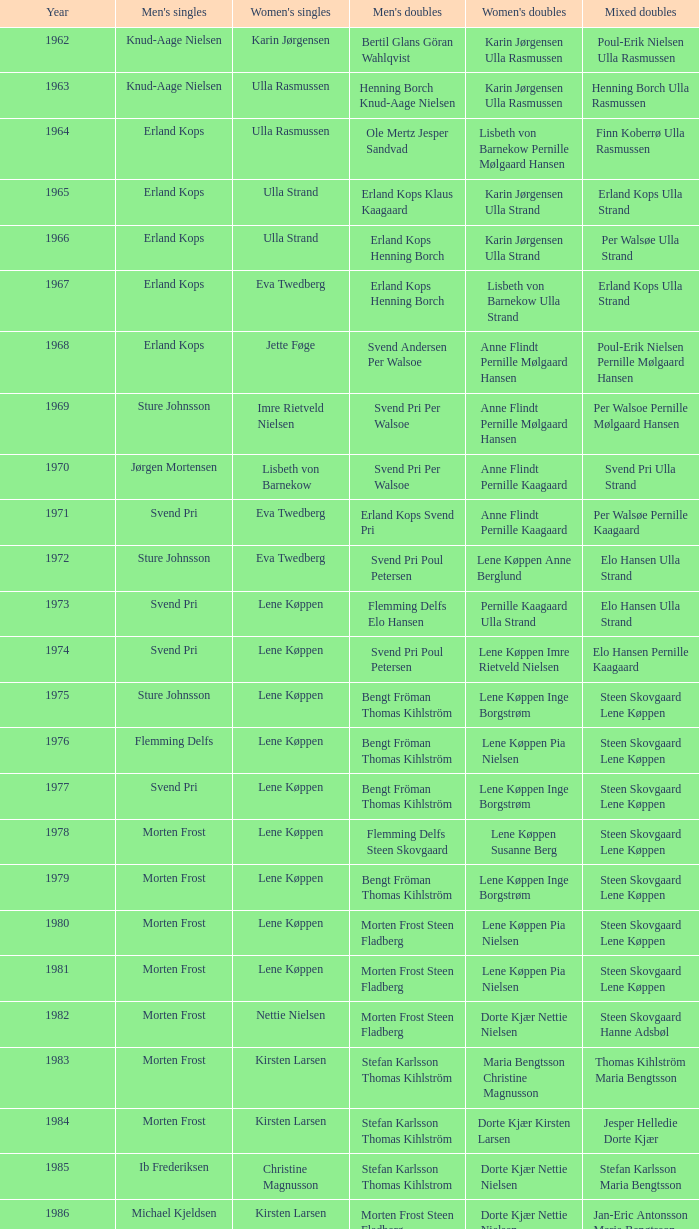Help me parse the entirety of this table. {'header': ['Year', "Men's singles", "Women's singles", "Men's doubles", "Women's doubles", 'Mixed doubles'], 'rows': [['1962', 'Knud-Aage Nielsen', 'Karin Jørgensen', 'Bertil Glans Göran Wahlqvist', 'Karin Jørgensen Ulla Rasmussen', 'Poul-Erik Nielsen Ulla Rasmussen'], ['1963', 'Knud-Aage Nielsen', 'Ulla Rasmussen', 'Henning Borch Knud-Aage Nielsen', 'Karin Jørgensen Ulla Rasmussen', 'Henning Borch Ulla Rasmussen'], ['1964', 'Erland Kops', 'Ulla Rasmussen', 'Ole Mertz Jesper Sandvad', 'Lisbeth von Barnekow Pernille Mølgaard Hansen', 'Finn Koberrø Ulla Rasmussen'], ['1965', 'Erland Kops', 'Ulla Strand', 'Erland Kops Klaus Kaagaard', 'Karin Jørgensen Ulla Strand', 'Erland Kops Ulla Strand'], ['1966', 'Erland Kops', 'Ulla Strand', 'Erland Kops Henning Borch', 'Karin Jørgensen Ulla Strand', 'Per Walsøe Ulla Strand'], ['1967', 'Erland Kops', 'Eva Twedberg', 'Erland Kops Henning Borch', 'Lisbeth von Barnekow Ulla Strand', 'Erland Kops Ulla Strand'], ['1968', 'Erland Kops', 'Jette Føge', 'Svend Andersen Per Walsoe', 'Anne Flindt Pernille Mølgaard Hansen', 'Poul-Erik Nielsen Pernille Mølgaard Hansen'], ['1969', 'Sture Johnsson', 'Imre Rietveld Nielsen', 'Svend Pri Per Walsoe', 'Anne Flindt Pernille Mølgaard Hansen', 'Per Walsoe Pernille Mølgaard Hansen'], ['1970', 'Jørgen Mortensen', 'Lisbeth von Barnekow', 'Svend Pri Per Walsoe', 'Anne Flindt Pernille Kaagaard', 'Svend Pri Ulla Strand'], ['1971', 'Svend Pri', 'Eva Twedberg', 'Erland Kops Svend Pri', 'Anne Flindt Pernille Kaagaard', 'Per Walsøe Pernille Kaagaard'], ['1972', 'Sture Johnsson', 'Eva Twedberg', 'Svend Pri Poul Petersen', 'Lene Køppen Anne Berglund', 'Elo Hansen Ulla Strand'], ['1973', 'Svend Pri', 'Lene Køppen', 'Flemming Delfs Elo Hansen', 'Pernille Kaagaard Ulla Strand', 'Elo Hansen Ulla Strand'], ['1974', 'Svend Pri', 'Lene Køppen', 'Svend Pri Poul Petersen', 'Lene Køppen Imre Rietveld Nielsen', 'Elo Hansen Pernille Kaagaard'], ['1975', 'Sture Johnsson', 'Lene Køppen', 'Bengt Fröman Thomas Kihlström', 'Lene Køppen Inge Borgstrøm', 'Steen Skovgaard Lene Køppen'], ['1976', 'Flemming Delfs', 'Lene Køppen', 'Bengt Fröman Thomas Kihlström', 'Lene Køppen Pia Nielsen', 'Steen Skovgaard Lene Køppen'], ['1977', 'Svend Pri', 'Lene Køppen', 'Bengt Fröman Thomas Kihlström', 'Lene Køppen Inge Borgstrøm', 'Steen Skovgaard Lene Køppen'], ['1978', 'Morten Frost', 'Lene Køppen', 'Flemming Delfs Steen Skovgaard', 'Lene Køppen Susanne Berg', 'Steen Skovgaard Lene Køppen'], ['1979', 'Morten Frost', 'Lene Køppen', 'Bengt Fröman Thomas Kihlström', 'Lene Køppen Inge Borgstrøm', 'Steen Skovgaard Lene Køppen'], ['1980', 'Morten Frost', 'Lene Køppen', 'Morten Frost Steen Fladberg', 'Lene Køppen Pia Nielsen', 'Steen Skovgaard Lene Køppen'], ['1981', 'Morten Frost', 'Lene Køppen', 'Morten Frost Steen Fladberg', 'Lene Køppen Pia Nielsen', 'Steen Skovgaard Lene Køppen'], ['1982', 'Morten Frost', 'Nettie Nielsen', 'Morten Frost Steen Fladberg', 'Dorte Kjær Nettie Nielsen', 'Steen Skovgaard Hanne Adsbøl'], ['1983', 'Morten Frost', 'Kirsten Larsen', 'Stefan Karlsson Thomas Kihlström', 'Maria Bengtsson Christine Magnusson', 'Thomas Kihlström Maria Bengtsson'], ['1984', 'Morten Frost', 'Kirsten Larsen', 'Stefan Karlsson Thomas Kihlström', 'Dorte Kjær Kirsten Larsen', 'Jesper Helledie Dorte Kjær'], ['1985', 'Ib Frederiksen', 'Christine Magnusson', 'Stefan Karlsson Thomas Kihlstrom', 'Dorte Kjær Nettie Nielsen', 'Stefan Karlsson Maria Bengtsson'], ['1986', 'Michael Kjeldsen', 'Kirsten Larsen', 'Morten Frost Steen Fladberg', 'Dorte Kjær Nettie Nielsen', 'Jan-Eric Antonsson Maria Bengtsson'], ['1987', 'Michael Kjeldsen', 'Christina Bostofte', 'Steen Fladberg Jan Paulsen', 'Dorte Kjær Nettie Nielsen', 'Jesper Knudsen Nettie Nielsen'], ['1988', 'Morten Frost', 'Kirsten Larsen', 'Jens Peter Nierhoff Michael Kjeldsen', 'Dorte Kjær Nettie Nielsen', 'Jesper Knudsen Nettie Nielsen'], ['1990', 'Poul Erik Hoyer Larsen', 'Pernille Nedergaard', 'Thomas Stuer-Lauridsen Max Gandrup', 'Dorte Kjær Lotte Olsen', 'Thomas Lund Pernille Dupont'], ['1992', 'Thomas Stuer-Lauridsen', 'Christine Magnusson', 'Jon Holst-Christensen Jan Paulsen', 'Christine Magnusson Lim Xiao Qing', 'Par Gunnar Jönsson Maria Bengtsson'], ['1995', 'Thomas Stuer-Lauridsen', 'Lim Xiao Qing', 'Michael Søgaard Henrik Svarrer', 'Rikke Olsen Helene Kirkegaard', 'Michael Søgaard Rikke Olsen'], ['1997', 'Peter Rasmussen', 'Camilla Martin', 'Jesper Larsen Jens Eriksen', 'Rikke Olsen Helene Kirkegaard', 'Jens Eriksen Marlene Thomsen'], ['1999', 'Thomas Johansson', 'Mette Sørensen', 'Thomas Stavngaard Lars Paaske', 'Ann-Lou Jørgensen Mette Schjoldager', 'Fredrik Bergström Jenny Karlsson']]} When pernille nedergaard secured the women's singles victory, who emerged as the winners of the men's doubles? Thomas Stuer-Lauridsen Max Gandrup. 